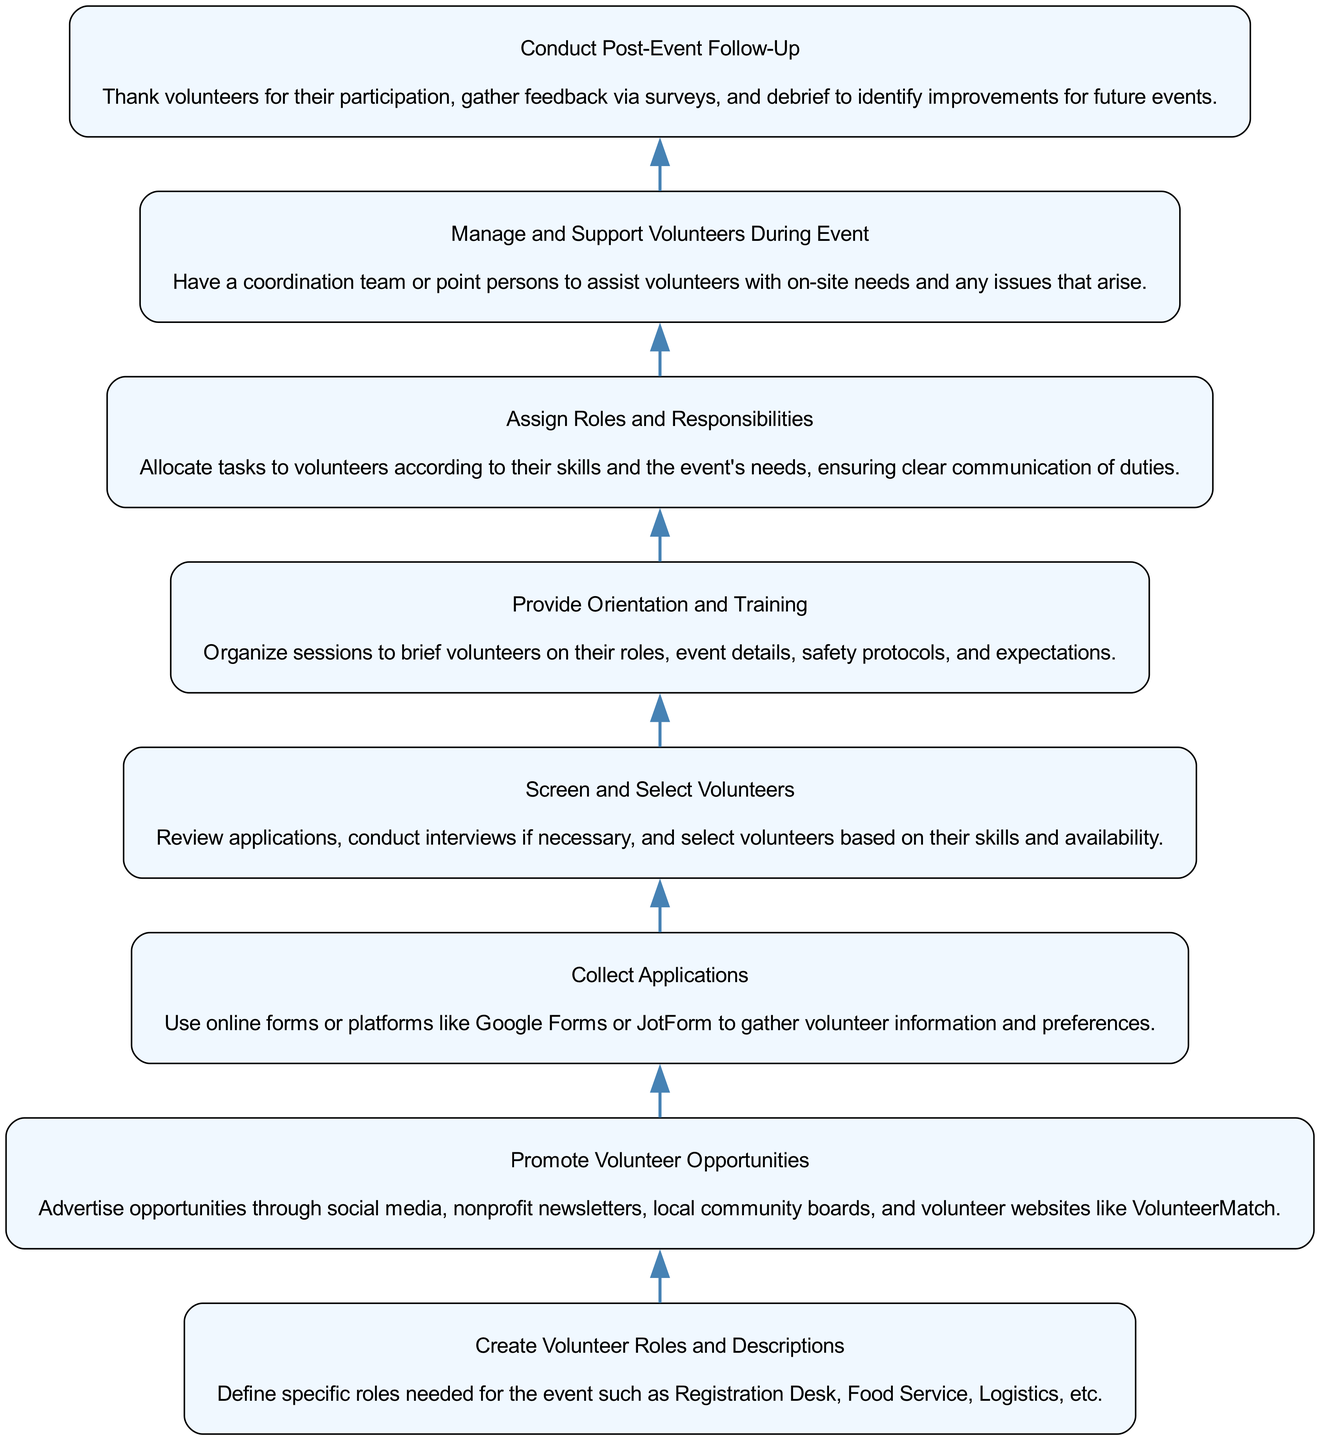What is the first step in the Volunteer Recruitment Process? The first step listed in the diagram is "Create Volunteer Roles and Descriptions." It is the first node at the bottom of the flow chart.
Answer: Create Volunteer Roles and Descriptions How many steps are there in total? The diagram contains a total of eight steps, each representing a stage in the volunteer recruitment process. This is counted by looking at the number of nodes in the flow chart.
Answer: 8 What comes after "Collect Applications"? After "Collect Applications," the next step in the process is "Screen and Select Volunteers." This is determined by following the arrows connecting the nodes in the flow chart.
Answer: Screen and Select Volunteers What are the roles assigned in the sixth step? The sixth step is "Assign Roles and Responsibilities," which involves allocating tasks to volunteers based on their skills and event needs. This information is found in the description of the sixth node.
Answer: Assign Roles and Responsibilities Which step involves gathering feedback? The step that involves gathering feedback is "Conduct Post-Event Follow-Up." It is found at the top of the flow chart and the description indicates that feedback is collected through surveys.
Answer: Conduct Post-Event Follow-Up What is the main purpose of the "Provide Orientation and Training" step? The main purpose of "Provide Orientation and Training" is to organize sessions to brief volunteers on their roles, event details, safety protocols, and expectations. This is derived from the details in the fifth node.
Answer: Organize sessions to brief volunteers How does the flow chart progress from volunteer opportunities to applications? The flow chart shows that after "Promote Volunteer Opportunities," the next step is "Collect Applications." This is seen by following the arrows from the second node to the third node, indicating the progression from promotion to application collection.
Answer: Collect Applications Which step ensures volunteer support during the event? The step that ensures volunteer support during the event is "Manage and Support Volunteers During Event." This is the seventh step in the flow, which emphasizes on-site assistance and addressing any issues.
Answer: Manage and Support Volunteers During Event 